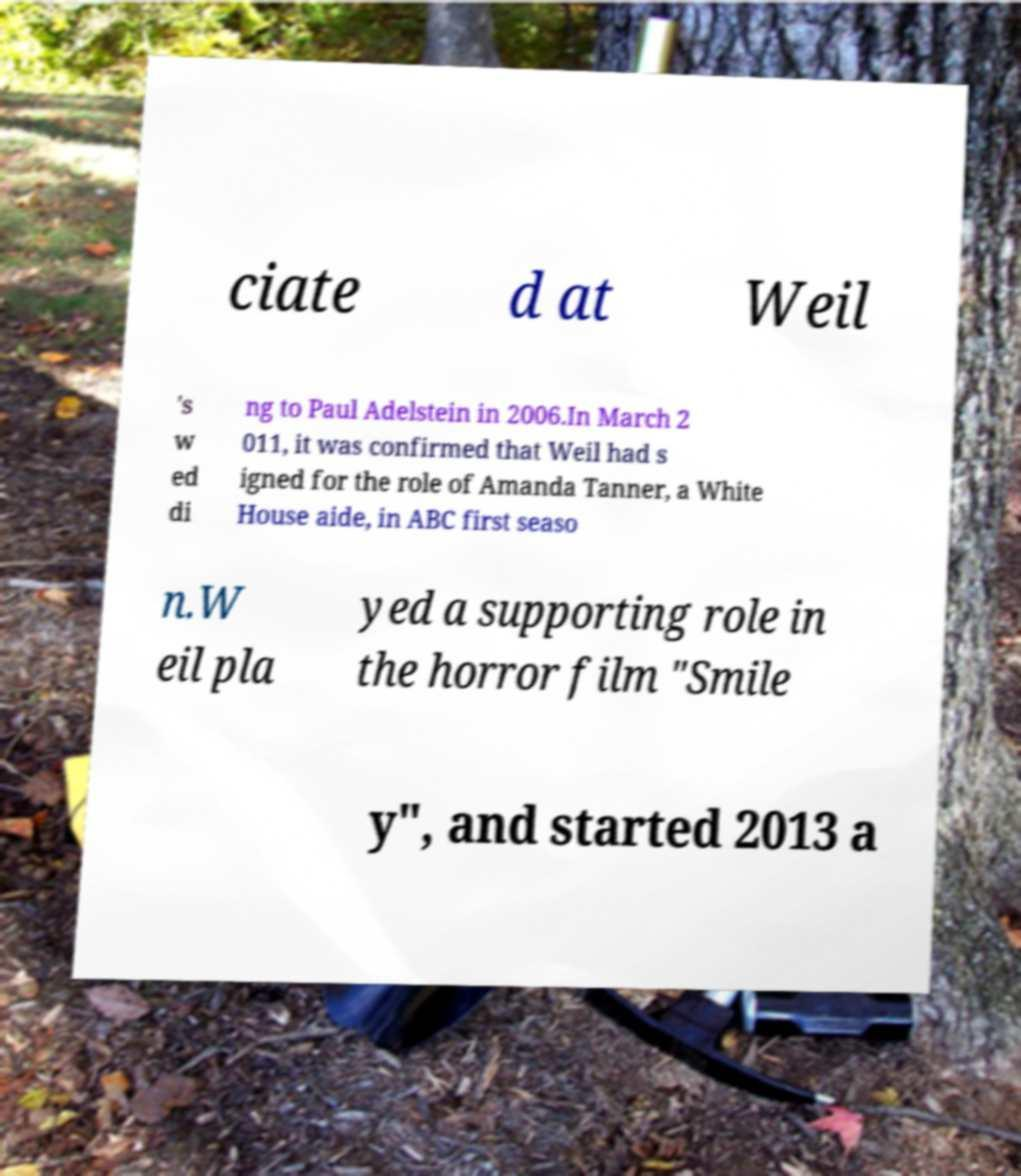Please read and relay the text visible in this image. What does it say? ciate d at Weil 's w ed di ng to Paul Adelstein in 2006.In March 2 011, it was confirmed that Weil had s igned for the role of Amanda Tanner, a White House aide, in ABC first seaso n.W eil pla yed a supporting role in the horror film "Smile y", and started 2013 a 